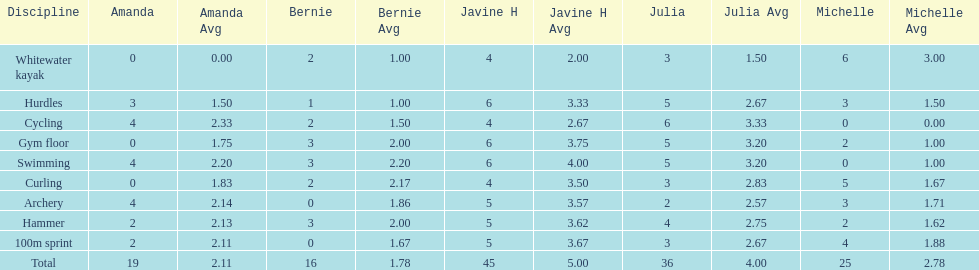Who scored the least on whitewater kayak? Amanda. 